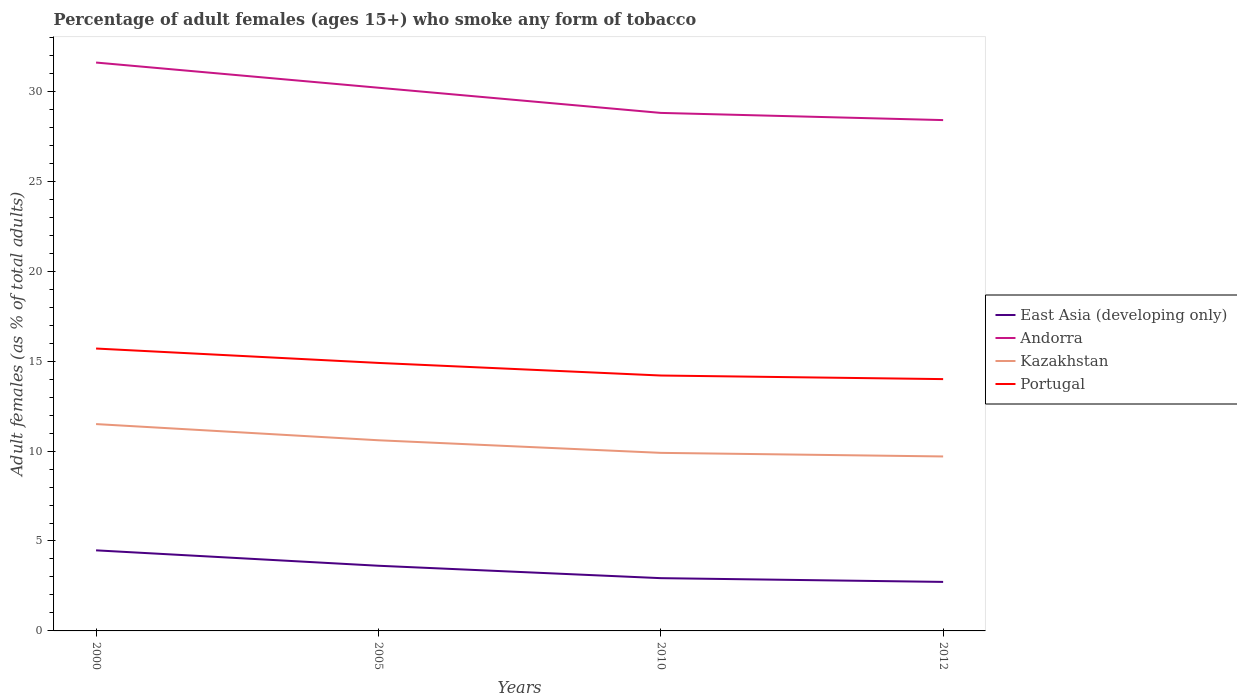Does the line corresponding to Andorra intersect with the line corresponding to East Asia (developing only)?
Make the answer very short. No. In which year was the percentage of adult females who smoke in East Asia (developing only) maximum?
Keep it short and to the point. 2012. What is the total percentage of adult females who smoke in Portugal in the graph?
Provide a succinct answer. 1.7. What is the difference between the highest and the second highest percentage of adult females who smoke in Portugal?
Ensure brevity in your answer.  1.7. What is the difference between the highest and the lowest percentage of adult females who smoke in East Asia (developing only)?
Provide a short and direct response. 2. How many lines are there?
Give a very brief answer. 4. What is the difference between two consecutive major ticks on the Y-axis?
Ensure brevity in your answer.  5. Does the graph contain grids?
Keep it short and to the point. No. How many legend labels are there?
Your answer should be compact. 4. How are the legend labels stacked?
Give a very brief answer. Vertical. What is the title of the graph?
Offer a terse response. Percentage of adult females (ages 15+) who smoke any form of tobacco. What is the label or title of the X-axis?
Make the answer very short. Years. What is the label or title of the Y-axis?
Provide a short and direct response. Adult females (as % of total adults). What is the Adult females (as % of total adults) in East Asia (developing only) in 2000?
Your answer should be very brief. 4.48. What is the Adult females (as % of total adults) of Andorra in 2000?
Give a very brief answer. 31.6. What is the Adult females (as % of total adults) of Kazakhstan in 2000?
Provide a succinct answer. 11.5. What is the Adult females (as % of total adults) of Portugal in 2000?
Provide a short and direct response. 15.7. What is the Adult females (as % of total adults) of East Asia (developing only) in 2005?
Provide a succinct answer. 3.62. What is the Adult females (as % of total adults) in Andorra in 2005?
Make the answer very short. 30.2. What is the Adult females (as % of total adults) of Kazakhstan in 2005?
Your answer should be compact. 10.6. What is the Adult females (as % of total adults) of East Asia (developing only) in 2010?
Your answer should be very brief. 2.93. What is the Adult females (as % of total adults) of Andorra in 2010?
Keep it short and to the point. 28.8. What is the Adult females (as % of total adults) in Kazakhstan in 2010?
Offer a very short reply. 9.9. What is the Adult females (as % of total adults) of Portugal in 2010?
Provide a succinct answer. 14.2. What is the Adult females (as % of total adults) in East Asia (developing only) in 2012?
Give a very brief answer. 2.72. What is the Adult females (as % of total adults) in Andorra in 2012?
Keep it short and to the point. 28.4. What is the Adult females (as % of total adults) in Portugal in 2012?
Keep it short and to the point. 14. Across all years, what is the maximum Adult females (as % of total adults) of East Asia (developing only)?
Your answer should be compact. 4.48. Across all years, what is the maximum Adult females (as % of total adults) of Andorra?
Your answer should be very brief. 31.6. Across all years, what is the maximum Adult females (as % of total adults) of Kazakhstan?
Your answer should be compact. 11.5. Across all years, what is the minimum Adult females (as % of total adults) of East Asia (developing only)?
Offer a very short reply. 2.72. Across all years, what is the minimum Adult females (as % of total adults) of Andorra?
Your response must be concise. 28.4. Across all years, what is the minimum Adult females (as % of total adults) of Portugal?
Offer a terse response. 14. What is the total Adult females (as % of total adults) of East Asia (developing only) in the graph?
Your response must be concise. 13.76. What is the total Adult females (as % of total adults) of Andorra in the graph?
Offer a very short reply. 119. What is the total Adult females (as % of total adults) in Kazakhstan in the graph?
Keep it short and to the point. 41.7. What is the total Adult females (as % of total adults) in Portugal in the graph?
Make the answer very short. 58.8. What is the difference between the Adult females (as % of total adults) in East Asia (developing only) in 2000 and that in 2005?
Offer a terse response. 0.86. What is the difference between the Adult females (as % of total adults) in East Asia (developing only) in 2000 and that in 2010?
Your answer should be compact. 1.55. What is the difference between the Adult females (as % of total adults) of Andorra in 2000 and that in 2010?
Offer a terse response. 2.8. What is the difference between the Adult females (as % of total adults) in Kazakhstan in 2000 and that in 2010?
Provide a short and direct response. 1.6. What is the difference between the Adult females (as % of total adults) in East Asia (developing only) in 2000 and that in 2012?
Your answer should be very brief. 1.76. What is the difference between the Adult females (as % of total adults) in Kazakhstan in 2000 and that in 2012?
Your response must be concise. 1.8. What is the difference between the Adult females (as % of total adults) in Portugal in 2000 and that in 2012?
Give a very brief answer. 1.7. What is the difference between the Adult females (as % of total adults) in East Asia (developing only) in 2005 and that in 2010?
Your response must be concise. 0.69. What is the difference between the Adult females (as % of total adults) of Kazakhstan in 2005 and that in 2010?
Offer a terse response. 0.7. What is the difference between the Adult females (as % of total adults) in East Asia (developing only) in 2005 and that in 2012?
Provide a short and direct response. 0.9. What is the difference between the Adult females (as % of total adults) in East Asia (developing only) in 2010 and that in 2012?
Provide a short and direct response. 0.21. What is the difference between the Adult females (as % of total adults) in East Asia (developing only) in 2000 and the Adult females (as % of total adults) in Andorra in 2005?
Your answer should be very brief. -25.72. What is the difference between the Adult females (as % of total adults) in East Asia (developing only) in 2000 and the Adult females (as % of total adults) in Kazakhstan in 2005?
Ensure brevity in your answer.  -6.12. What is the difference between the Adult females (as % of total adults) in East Asia (developing only) in 2000 and the Adult females (as % of total adults) in Portugal in 2005?
Give a very brief answer. -10.42. What is the difference between the Adult females (as % of total adults) of Andorra in 2000 and the Adult females (as % of total adults) of Kazakhstan in 2005?
Provide a succinct answer. 21. What is the difference between the Adult females (as % of total adults) in Kazakhstan in 2000 and the Adult females (as % of total adults) in Portugal in 2005?
Provide a succinct answer. -3.4. What is the difference between the Adult females (as % of total adults) of East Asia (developing only) in 2000 and the Adult females (as % of total adults) of Andorra in 2010?
Your answer should be very brief. -24.32. What is the difference between the Adult females (as % of total adults) of East Asia (developing only) in 2000 and the Adult females (as % of total adults) of Kazakhstan in 2010?
Your answer should be compact. -5.42. What is the difference between the Adult females (as % of total adults) of East Asia (developing only) in 2000 and the Adult females (as % of total adults) of Portugal in 2010?
Keep it short and to the point. -9.72. What is the difference between the Adult females (as % of total adults) in Andorra in 2000 and the Adult females (as % of total adults) in Kazakhstan in 2010?
Ensure brevity in your answer.  21.7. What is the difference between the Adult females (as % of total adults) of Andorra in 2000 and the Adult females (as % of total adults) of Portugal in 2010?
Your response must be concise. 17.4. What is the difference between the Adult females (as % of total adults) of East Asia (developing only) in 2000 and the Adult females (as % of total adults) of Andorra in 2012?
Ensure brevity in your answer.  -23.92. What is the difference between the Adult females (as % of total adults) of East Asia (developing only) in 2000 and the Adult females (as % of total adults) of Kazakhstan in 2012?
Your response must be concise. -5.22. What is the difference between the Adult females (as % of total adults) of East Asia (developing only) in 2000 and the Adult females (as % of total adults) of Portugal in 2012?
Provide a short and direct response. -9.52. What is the difference between the Adult females (as % of total adults) of Andorra in 2000 and the Adult females (as % of total adults) of Kazakhstan in 2012?
Provide a succinct answer. 21.9. What is the difference between the Adult females (as % of total adults) in Andorra in 2000 and the Adult females (as % of total adults) in Portugal in 2012?
Give a very brief answer. 17.6. What is the difference between the Adult females (as % of total adults) of Kazakhstan in 2000 and the Adult females (as % of total adults) of Portugal in 2012?
Offer a very short reply. -2.5. What is the difference between the Adult females (as % of total adults) in East Asia (developing only) in 2005 and the Adult females (as % of total adults) in Andorra in 2010?
Offer a terse response. -25.18. What is the difference between the Adult females (as % of total adults) in East Asia (developing only) in 2005 and the Adult females (as % of total adults) in Kazakhstan in 2010?
Keep it short and to the point. -6.28. What is the difference between the Adult females (as % of total adults) in East Asia (developing only) in 2005 and the Adult females (as % of total adults) in Portugal in 2010?
Keep it short and to the point. -10.58. What is the difference between the Adult females (as % of total adults) in Andorra in 2005 and the Adult females (as % of total adults) in Kazakhstan in 2010?
Your answer should be compact. 20.3. What is the difference between the Adult females (as % of total adults) of Kazakhstan in 2005 and the Adult females (as % of total adults) of Portugal in 2010?
Your answer should be compact. -3.6. What is the difference between the Adult females (as % of total adults) in East Asia (developing only) in 2005 and the Adult females (as % of total adults) in Andorra in 2012?
Keep it short and to the point. -24.78. What is the difference between the Adult females (as % of total adults) of East Asia (developing only) in 2005 and the Adult females (as % of total adults) of Kazakhstan in 2012?
Ensure brevity in your answer.  -6.08. What is the difference between the Adult females (as % of total adults) in East Asia (developing only) in 2005 and the Adult females (as % of total adults) in Portugal in 2012?
Provide a succinct answer. -10.38. What is the difference between the Adult females (as % of total adults) of Andorra in 2005 and the Adult females (as % of total adults) of Kazakhstan in 2012?
Your answer should be very brief. 20.5. What is the difference between the Adult females (as % of total adults) in Andorra in 2005 and the Adult females (as % of total adults) in Portugal in 2012?
Ensure brevity in your answer.  16.2. What is the difference between the Adult females (as % of total adults) in East Asia (developing only) in 2010 and the Adult females (as % of total adults) in Andorra in 2012?
Keep it short and to the point. -25.47. What is the difference between the Adult females (as % of total adults) in East Asia (developing only) in 2010 and the Adult females (as % of total adults) in Kazakhstan in 2012?
Provide a short and direct response. -6.77. What is the difference between the Adult females (as % of total adults) in East Asia (developing only) in 2010 and the Adult females (as % of total adults) in Portugal in 2012?
Your answer should be compact. -11.07. What is the difference between the Adult females (as % of total adults) of Andorra in 2010 and the Adult females (as % of total adults) of Portugal in 2012?
Make the answer very short. 14.8. What is the difference between the Adult females (as % of total adults) in Kazakhstan in 2010 and the Adult females (as % of total adults) in Portugal in 2012?
Keep it short and to the point. -4.1. What is the average Adult females (as % of total adults) in East Asia (developing only) per year?
Offer a terse response. 3.44. What is the average Adult females (as % of total adults) in Andorra per year?
Provide a short and direct response. 29.75. What is the average Adult females (as % of total adults) of Kazakhstan per year?
Keep it short and to the point. 10.43. What is the average Adult females (as % of total adults) in Portugal per year?
Offer a terse response. 14.7. In the year 2000, what is the difference between the Adult females (as % of total adults) in East Asia (developing only) and Adult females (as % of total adults) in Andorra?
Make the answer very short. -27.12. In the year 2000, what is the difference between the Adult females (as % of total adults) in East Asia (developing only) and Adult females (as % of total adults) in Kazakhstan?
Offer a very short reply. -7.02. In the year 2000, what is the difference between the Adult females (as % of total adults) in East Asia (developing only) and Adult females (as % of total adults) in Portugal?
Offer a very short reply. -11.22. In the year 2000, what is the difference between the Adult females (as % of total adults) of Andorra and Adult females (as % of total adults) of Kazakhstan?
Your answer should be very brief. 20.1. In the year 2000, what is the difference between the Adult females (as % of total adults) of Andorra and Adult females (as % of total adults) of Portugal?
Give a very brief answer. 15.9. In the year 2005, what is the difference between the Adult females (as % of total adults) of East Asia (developing only) and Adult females (as % of total adults) of Andorra?
Provide a short and direct response. -26.58. In the year 2005, what is the difference between the Adult females (as % of total adults) of East Asia (developing only) and Adult females (as % of total adults) of Kazakhstan?
Offer a very short reply. -6.98. In the year 2005, what is the difference between the Adult females (as % of total adults) in East Asia (developing only) and Adult females (as % of total adults) in Portugal?
Make the answer very short. -11.28. In the year 2005, what is the difference between the Adult females (as % of total adults) of Andorra and Adult females (as % of total adults) of Kazakhstan?
Your response must be concise. 19.6. In the year 2005, what is the difference between the Adult females (as % of total adults) of Andorra and Adult females (as % of total adults) of Portugal?
Offer a terse response. 15.3. In the year 2005, what is the difference between the Adult females (as % of total adults) in Kazakhstan and Adult females (as % of total adults) in Portugal?
Your response must be concise. -4.3. In the year 2010, what is the difference between the Adult females (as % of total adults) in East Asia (developing only) and Adult females (as % of total adults) in Andorra?
Your answer should be very brief. -25.87. In the year 2010, what is the difference between the Adult females (as % of total adults) of East Asia (developing only) and Adult females (as % of total adults) of Kazakhstan?
Provide a short and direct response. -6.97. In the year 2010, what is the difference between the Adult females (as % of total adults) in East Asia (developing only) and Adult females (as % of total adults) in Portugal?
Make the answer very short. -11.27. In the year 2010, what is the difference between the Adult females (as % of total adults) of Andorra and Adult females (as % of total adults) of Kazakhstan?
Provide a short and direct response. 18.9. In the year 2012, what is the difference between the Adult females (as % of total adults) in East Asia (developing only) and Adult females (as % of total adults) in Andorra?
Offer a very short reply. -25.68. In the year 2012, what is the difference between the Adult females (as % of total adults) of East Asia (developing only) and Adult females (as % of total adults) of Kazakhstan?
Ensure brevity in your answer.  -6.98. In the year 2012, what is the difference between the Adult females (as % of total adults) of East Asia (developing only) and Adult females (as % of total adults) of Portugal?
Offer a terse response. -11.28. In the year 2012, what is the difference between the Adult females (as % of total adults) in Andorra and Adult females (as % of total adults) in Kazakhstan?
Keep it short and to the point. 18.7. In the year 2012, what is the difference between the Adult females (as % of total adults) in Andorra and Adult females (as % of total adults) in Portugal?
Your answer should be compact. 14.4. What is the ratio of the Adult females (as % of total adults) of East Asia (developing only) in 2000 to that in 2005?
Ensure brevity in your answer.  1.24. What is the ratio of the Adult females (as % of total adults) of Andorra in 2000 to that in 2005?
Give a very brief answer. 1.05. What is the ratio of the Adult females (as % of total adults) of Kazakhstan in 2000 to that in 2005?
Ensure brevity in your answer.  1.08. What is the ratio of the Adult females (as % of total adults) in Portugal in 2000 to that in 2005?
Your answer should be compact. 1.05. What is the ratio of the Adult females (as % of total adults) in East Asia (developing only) in 2000 to that in 2010?
Your response must be concise. 1.53. What is the ratio of the Adult females (as % of total adults) in Andorra in 2000 to that in 2010?
Make the answer very short. 1.1. What is the ratio of the Adult females (as % of total adults) in Kazakhstan in 2000 to that in 2010?
Offer a very short reply. 1.16. What is the ratio of the Adult females (as % of total adults) in Portugal in 2000 to that in 2010?
Make the answer very short. 1.11. What is the ratio of the Adult females (as % of total adults) of East Asia (developing only) in 2000 to that in 2012?
Ensure brevity in your answer.  1.64. What is the ratio of the Adult females (as % of total adults) of Andorra in 2000 to that in 2012?
Ensure brevity in your answer.  1.11. What is the ratio of the Adult females (as % of total adults) in Kazakhstan in 2000 to that in 2012?
Your answer should be very brief. 1.19. What is the ratio of the Adult females (as % of total adults) of Portugal in 2000 to that in 2012?
Keep it short and to the point. 1.12. What is the ratio of the Adult females (as % of total adults) in East Asia (developing only) in 2005 to that in 2010?
Give a very brief answer. 1.24. What is the ratio of the Adult females (as % of total adults) of Andorra in 2005 to that in 2010?
Your answer should be very brief. 1.05. What is the ratio of the Adult females (as % of total adults) in Kazakhstan in 2005 to that in 2010?
Your response must be concise. 1.07. What is the ratio of the Adult females (as % of total adults) of Portugal in 2005 to that in 2010?
Provide a short and direct response. 1.05. What is the ratio of the Adult females (as % of total adults) of East Asia (developing only) in 2005 to that in 2012?
Offer a terse response. 1.33. What is the ratio of the Adult females (as % of total adults) of Andorra in 2005 to that in 2012?
Provide a succinct answer. 1.06. What is the ratio of the Adult females (as % of total adults) in Kazakhstan in 2005 to that in 2012?
Your answer should be compact. 1.09. What is the ratio of the Adult females (as % of total adults) of Portugal in 2005 to that in 2012?
Make the answer very short. 1.06. What is the ratio of the Adult females (as % of total adults) of East Asia (developing only) in 2010 to that in 2012?
Provide a succinct answer. 1.08. What is the ratio of the Adult females (as % of total adults) of Andorra in 2010 to that in 2012?
Offer a terse response. 1.01. What is the ratio of the Adult females (as % of total adults) in Kazakhstan in 2010 to that in 2012?
Provide a short and direct response. 1.02. What is the ratio of the Adult females (as % of total adults) in Portugal in 2010 to that in 2012?
Provide a succinct answer. 1.01. What is the difference between the highest and the second highest Adult females (as % of total adults) of East Asia (developing only)?
Provide a short and direct response. 0.86. What is the difference between the highest and the second highest Adult females (as % of total adults) in Andorra?
Keep it short and to the point. 1.4. What is the difference between the highest and the second highest Adult females (as % of total adults) of Kazakhstan?
Give a very brief answer. 0.9. What is the difference between the highest and the second highest Adult females (as % of total adults) in Portugal?
Make the answer very short. 0.8. What is the difference between the highest and the lowest Adult females (as % of total adults) of East Asia (developing only)?
Give a very brief answer. 1.76. What is the difference between the highest and the lowest Adult females (as % of total adults) of Andorra?
Make the answer very short. 3.2. What is the difference between the highest and the lowest Adult females (as % of total adults) in Kazakhstan?
Your answer should be compact. 1.8. 